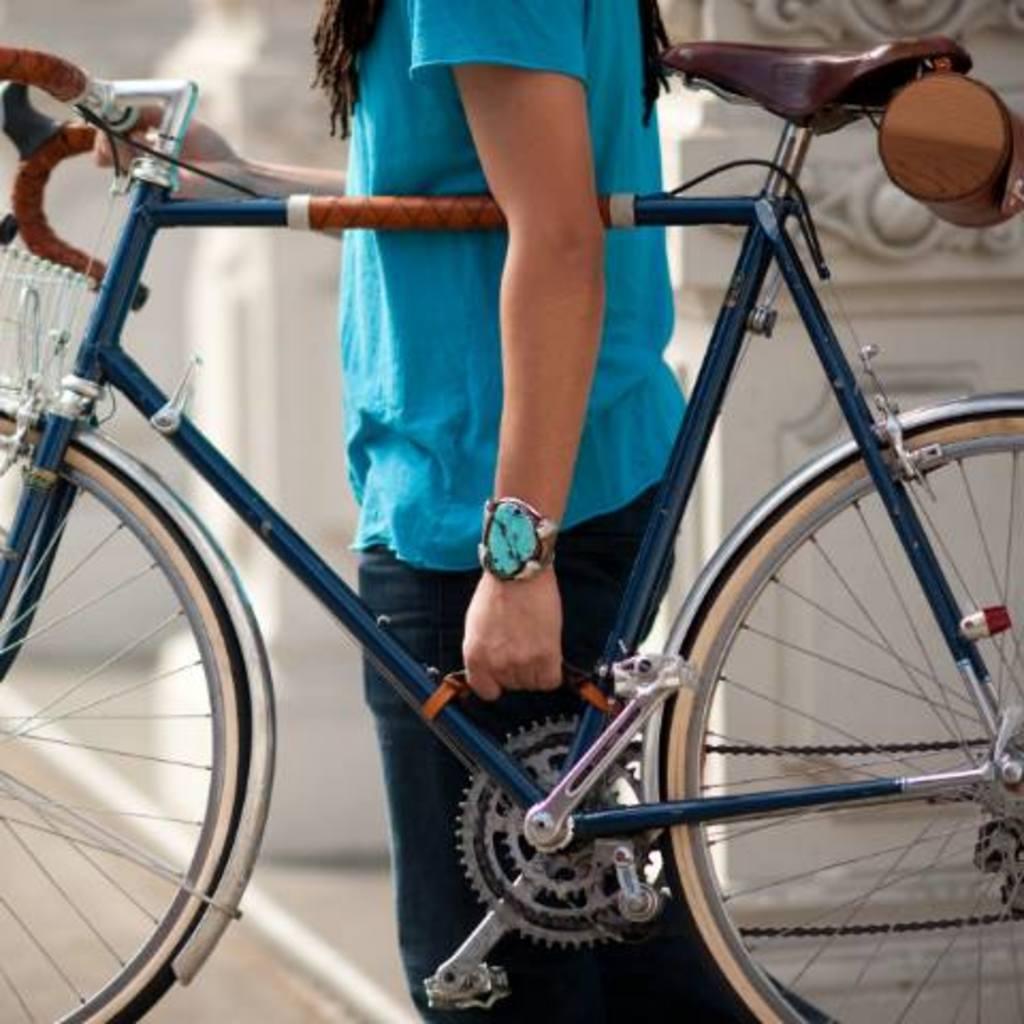Please provide a concise description of this image. Here we can see a person holding a bicycle. There is a blur background. 